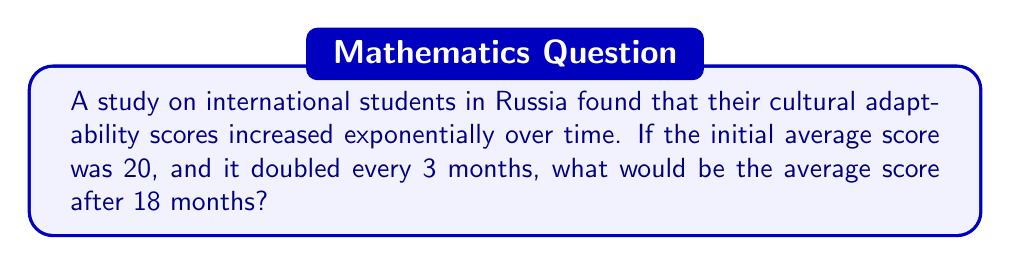What is the answer to this math problem? Let's approach this step-by-step:

1) First, we need to identify the key components of exponential growth:
   - Initial value: $a = 20$
   - Growth factor: $r = 2$ (doubles every 3 months)
   - Time periods: $t = 18 \div 3 = 6$ (18 months divided into 3-month periods)

2) The exponential growth formula is:
   $$ A = a \cdot r^t $$
   Where $A$ is the final amount, $a$ is the initial amount, $r$ is the growth factor, and $t$ is the number of time periods.

3) Plugging in our values:
   $$ A = 20 \cdot 2^6 $$

4) Now we need to calculate $2^6$:
   $$ 2^6 = 2 \cdot 2 \cdot 2 \cdot 2 \cdot 2 \cdot 2 = 64 $$

5) Finally, we multiply:
   $$ A = 20 \cdot 64 = 1280 $$

Therefore, after 18 months, the average cultural adaptability score would be 1280.
Answer: 1280 